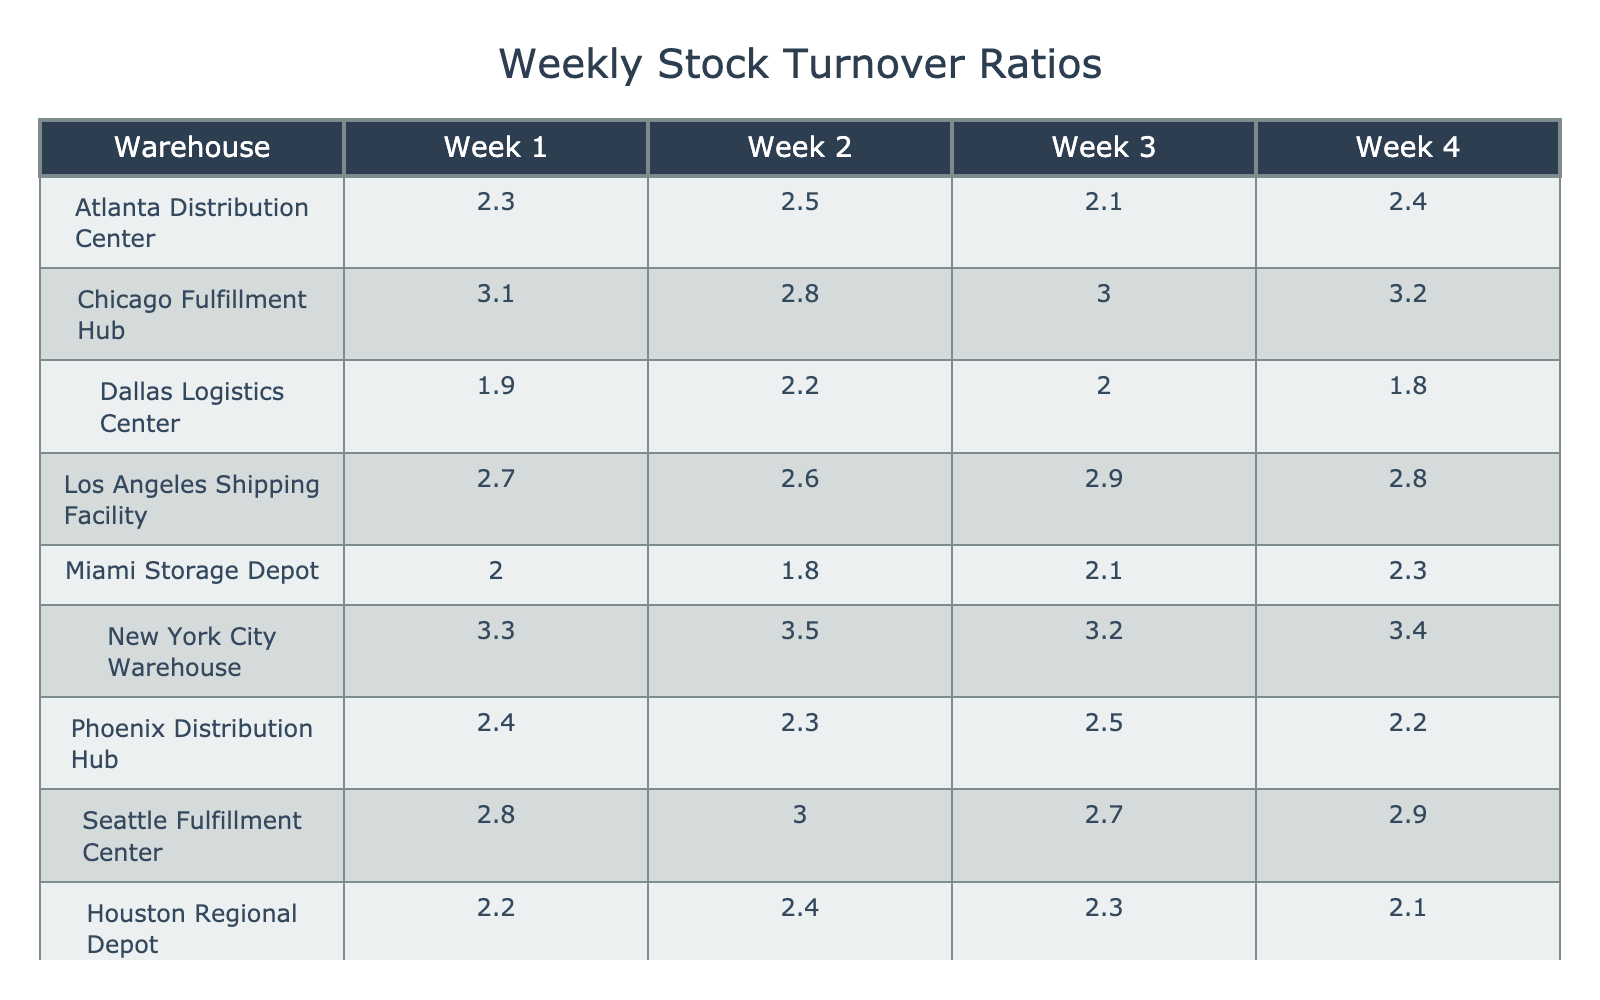What is the stock turnover ratio for the Chicago Fulfillment Hub in Week 3? The table shows that the value under the Chicago Fulfillment Hub for Week 3 is 3.0.
Answer: 3.0 Which warehouse had the highest stock turnover ratio in Week 4? Looking at Week 4, the highest value is found in the New York City Warehouse, which is 3.4.
Answer: New York City Warehouse What is the average stock turnover ratio for the Los Angeles Shipping Facility over all four weeks? To find the average, sum the values for the Los Angeles Shipping Facility: (2.7 + 2.6 + 2.9 + 2.8) = 11.0, then divide by 4 to get 11.0 / 4 = 2.75.
Answer: 2.75 Did the Miami Storage Depot experience a stock turnover ratio greater than 2.0 in Week 2? The table shows that the value for Week 2 is 1.8, which is less than 2.0.
Answer: No Is the stock turnover ratio for any week in the Dallas Logistics Center less than 1.9? Looking at the values, the lowest ratio for the Dallas Logistics Center is 1.8 in Week 4, which is less than 1.9.
Answer: Yes What is the difference in stock turnover ratios between the highest and lowest week for the Seattle Fulfillment Center? The highest ratio for Seattle is 3.0 in Week 2 and the lowest is 2.7 in Week 3. The difference is 3.0 - 2.7 = 0.3.
Answer: 0.3 Which warehouse shows a consistent increase in stock turnover ratios over the four weeks? Analyzing the ratios, the Chicago Fulfillment Hub increases from 2.8 in Week 2 to 3.2 in Week 4, indicating an upward trend.
Answer: Chicago Fulfillment Hub What percentage increase in the stock turnover ratio did the Atlanta Distribution Center experience from Week 1 to Week 4? The ratio increased from 2.3 in Week 1 to 2.4 in Week 4. The percentage increase is ((2.4 - 2.3) / 2.3) * 100 = 4.35%.
Answer: 4.35% Which warehouse had a turn ratio lower than the average of all Week 1 turnovers? The average turnover for Week 1 across all warehouses is (2.3 + 3.1 + 1.9 + 2.7 + 2.0 + 3.3 + 2.4 + 2.8 + 2.2 + 2.6) / 10 = 2.43. The Dallas Logistics Center at 1.9 is lower than this average.
Answer: Dallas Logistics Center How does the stock turnover in Week 3 for the New York City Warehouse compare with that of the Phoenix Distribution Hub? In Week 3, the New York City Warehouse has a turnover of 3.2, while the Phoenix Distribution Hub has 2.5. Since 3.2 > 2.5, New York has a higher turnover.
Answer: Higher What is the total stock turnover ratio for the Houston Regional Depot over the four weeks? The sum of the ratios for Houston is: 2.2 + 2.4 + 2.3 + 2.1 = 9.0.
Answer: 9.0 